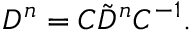Convert formula to latex. <formula><loc_0><loc_0><loc_500><loc_500>D ^ { n } = C \tilde { D } ^ { n } C ^ { - 1 } .</formula> 